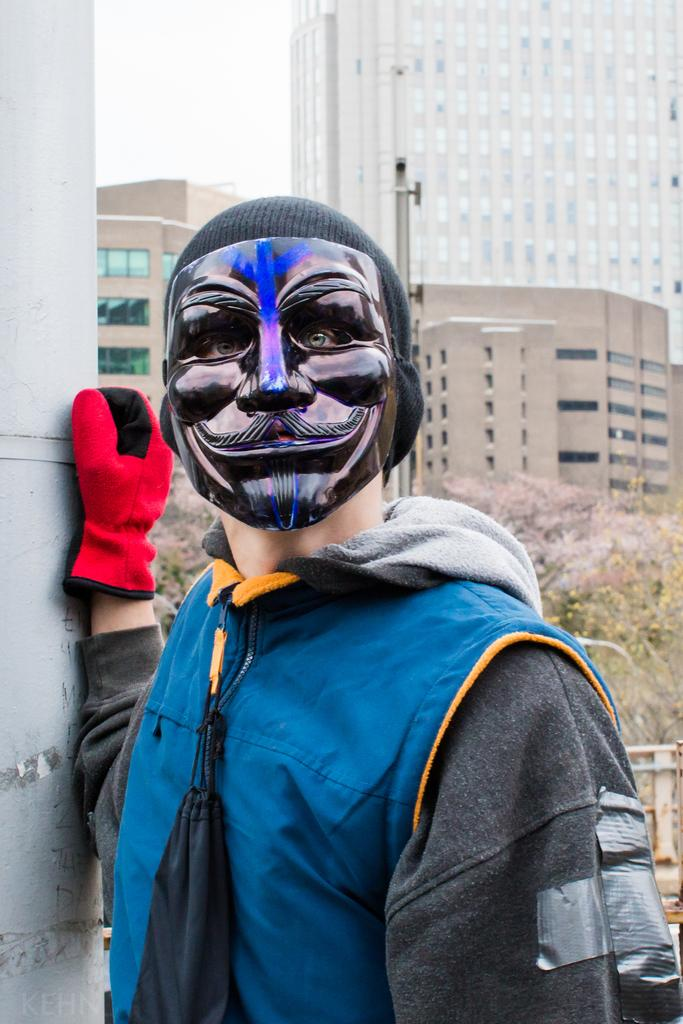Who is the main subject in the image? There is a boy in the image. What is the boy wearing? The boy is wearing a blue jacket and a mask. Where is the boy positioned in the image? The boy is standing in the front. What can be seen in the background of the image? There is a building in the background of the image. What type of coal is the boy using to adjust his watch in the image? There is no coal or watch present in the image, and therefore no such activity can be observed. 